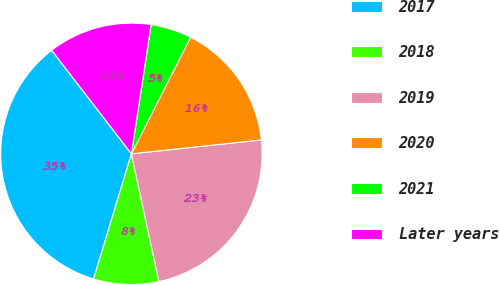Convert chart to OTSL. <chart><loc_0><loc_0><loc_500><loc_500><pie_chart><fcel>2017<fcel>2018<fcel>2019<fcel>2020<fcel>2021<fcel>Later years<nl><fcel>34.89%<fcel>8.05%<fcel>23.31%<fcel>15.83%<fcel>5.07%<fcel>12.85%<nl></chart> 